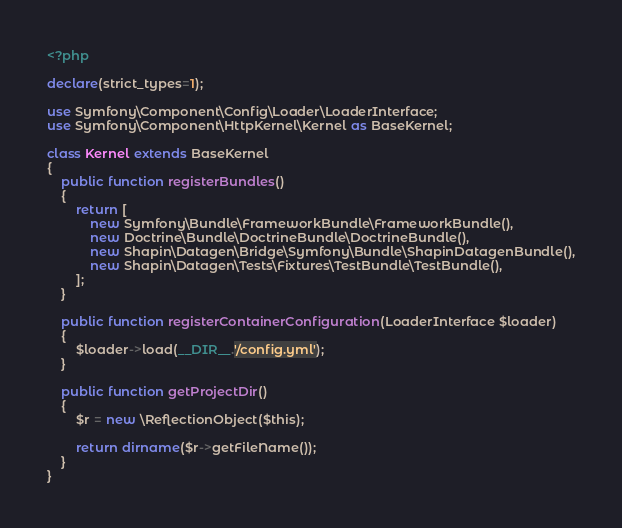<code> <loc_0><loc_0><loc_500><loc_500><_PHP_><?php

declare(strict_types=1);

use Symfony\Component\Config\Loader\LoaderInterface;
use Symfony\Component\HttpKernel\Kernel as BaseKernel;

class Kernel extends BaseKernel
{
    public function registerBundles()
    {
        return [
            new Symfony\Bundle\FrameworkBundle\FrameworkBundle(),
            new Doctrine\Bundle\DoctrineBundle\DoctrineBundle(),
            new Shapin\Datagen\Bridge\Symfony\Bundle\ShapinDatagenBundle(),
            new Shapin\Datagen\Tests\Fixtures\TestBundle\TestBundle(),
        ];
    }

    public function registerContainerConfiguration(LoaderInterface $loader)
    {
        $loader->load(__DIR__.'/config.yml');
    }

    public function getProjectDir()
    {
        $r = new \ReflectionObject($this);

        return dirname($r->getFileName());
    }
}
</code> 